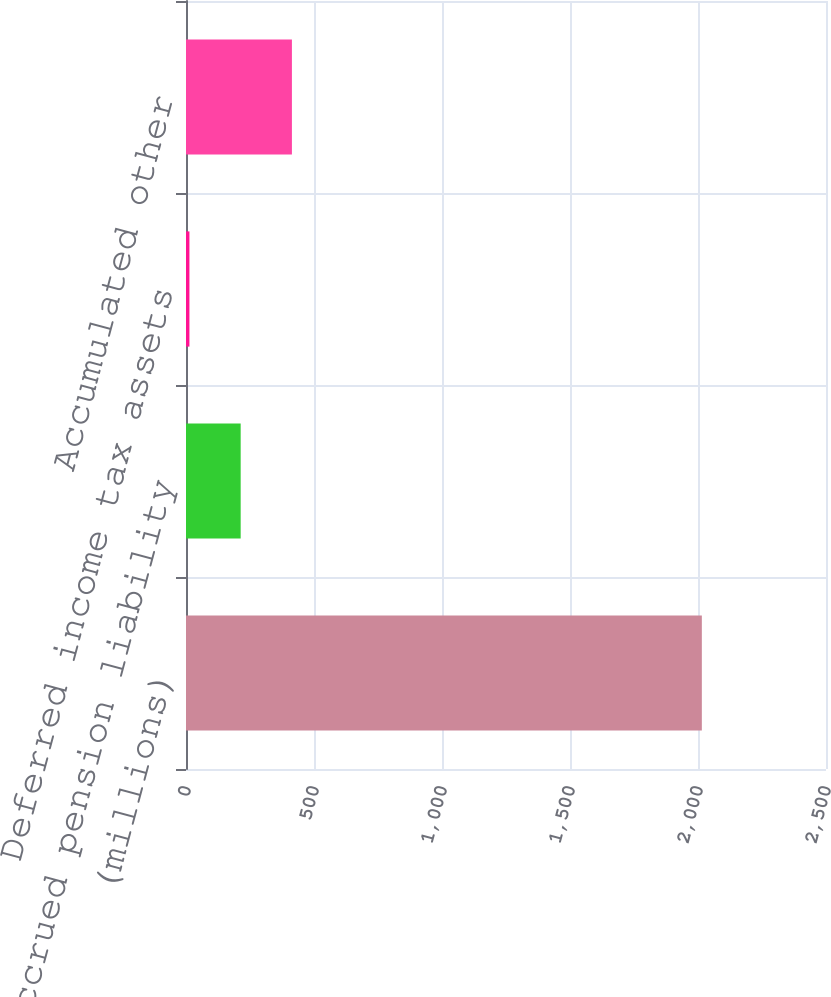Convert chart to OTSL. <chart><loc_0><loc_0><loc_500><loc_500><bar_chart><fcel>(millions)<fcel>Accrued pension liability<fcel>Deferred income tax assets<fcel>Accumulated other<nl><fcel>2015<fcel>213.56<fcel>13.4<fcel>413.72<nl></chart> 